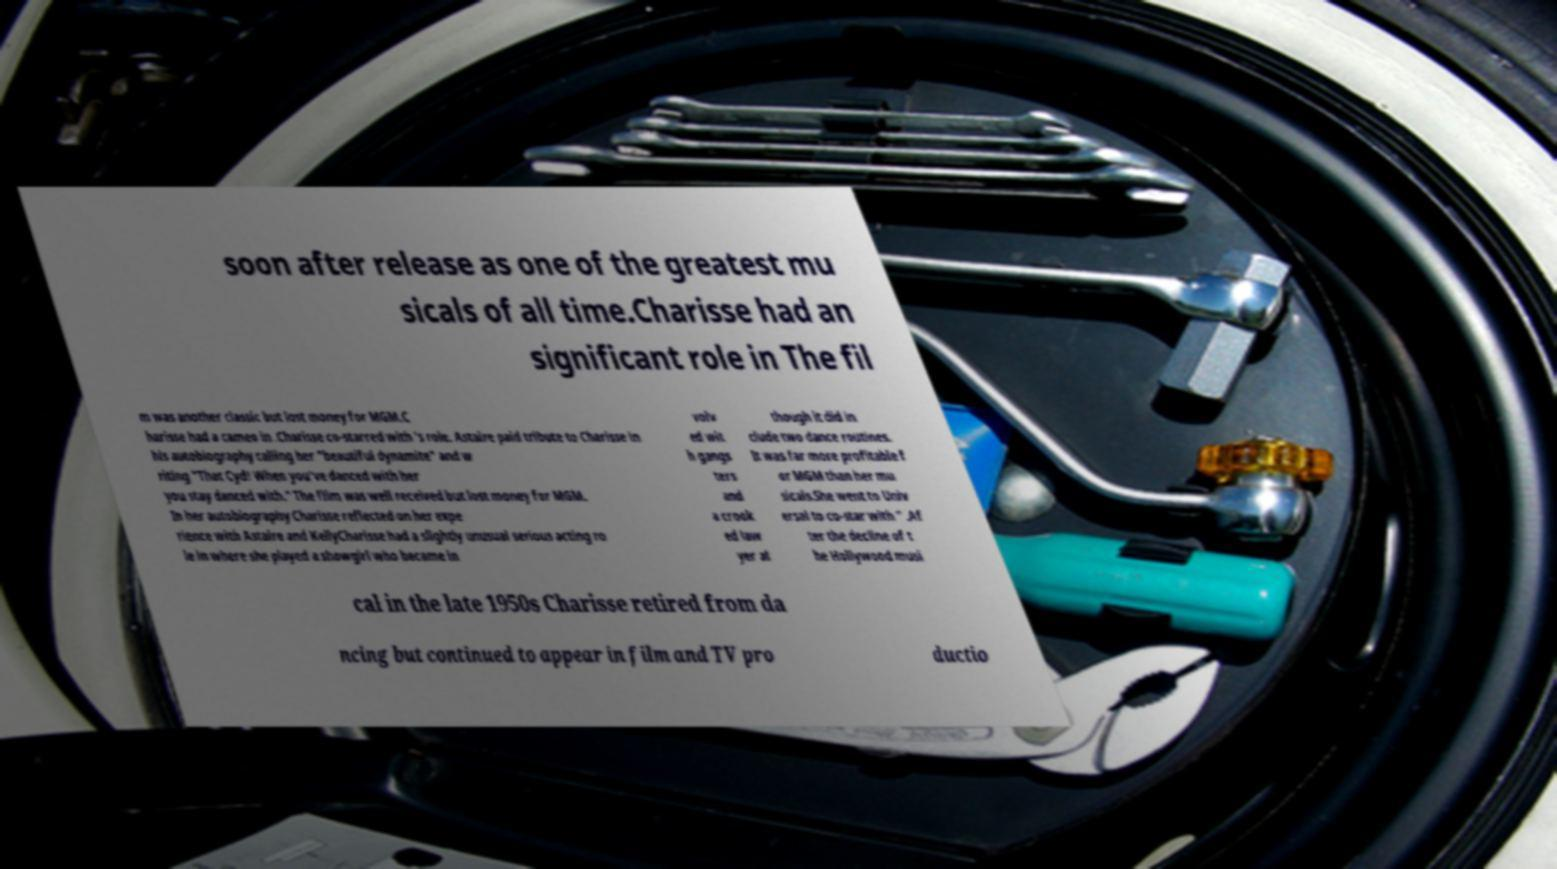Could you extract and type out the text from this image? soon after release as one of the greatest mu sicals of all time.Charisse had an significant role in The fil m was another classic but lost money for MGM.C harisse had a cameo in .Charisse co-starred with 's role. Astaire paid tribute to Charisse in his autobiography calling her "beautiful dynamite" and w riting "That Cyd! When you've danced with her you stay danced with." The film was well received but lost money for MGM. In her autobiography Charisse reflected on her expe rience with Astaire and KellyCharisse had a slightly unusual serious acting ro le in where she played a showgirl who became in volv ed wit h gangs ters and a crook ed law yer al though it did in clude two dance routines. It was far more profitable f or MGM than her mu sicals.She went to Univ ersal to co-star with " .Af ter the decline of t he Hollywood musi cal in the late 1950s Charisse retired from da ncing but continued to appear in film and TV pro ductio 